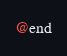Convert code to text. <code><loc_0><loc_0><loc_500><loc_500><_C_>@end
</code> 